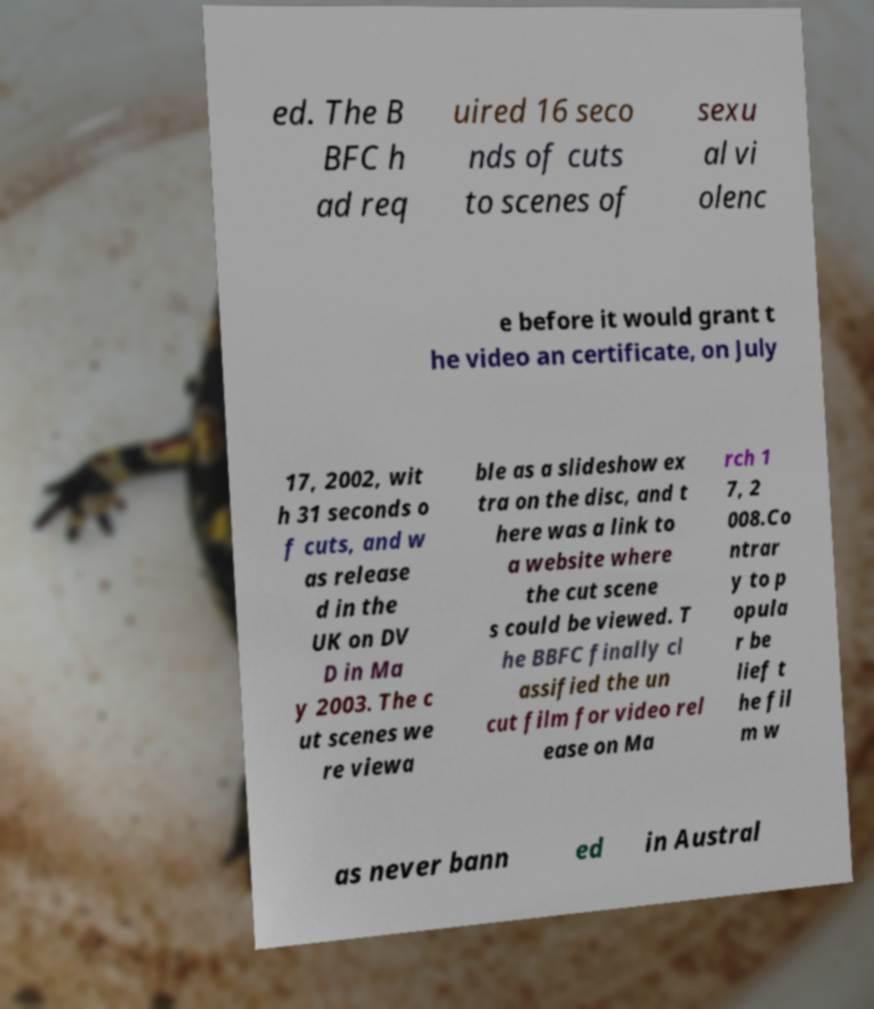Could you extract and type out the text from this image? ed. The B BFC h ad req uired 16 seco nds of cuts to scenes of sexu al vi olenc e before it would grant t he video an certificate, on July 17, 2002, wit h 31 seconds o f cuts, and w as release d in the UK on DV D in Ma y 2003. The c ut scenes we re viewa ble as a slideshow ex tra on the disc, and t here was a link to a website where the cut scene s could be viewed. T he BBFC finally cl assified the un cut film for video rel ease on Ma rch 1 7, 2 008.Co ntrar y to p opula r be lief t he fil m w as never bann ed in Austral 